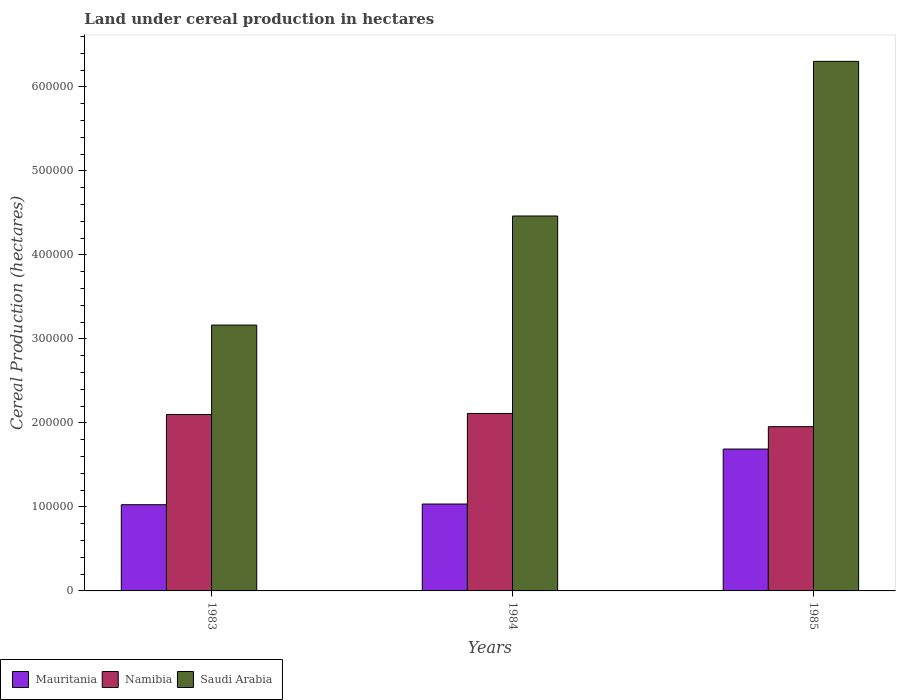How many groups of bars are there?
Provide a succinct answer. 3. Are the number of bars on each tick of the X-axis equal?
Your answer should be compact. Yes. How many bars are there on the 3rd tick from the left?
Offer a terse response. 3. What is the label of the 3rd group of bars from the left?
Your response must be concise. 1985. What is the land under cereal production in Mauritania in 1985?
Keep it short and to the point. 1.69e+05. Across all years, what is the maximum land under cereal production in Saudi Arabia?
Provide a short and direct response. 6.30e+05. Across all years, what is the minimum land under cereal production in Namibia?
Offer a very short reply. 1.96e+05. What is the total land under cereal production in Mauritania in the graph?
Give a very brief answer. 3.75e+05. What is the difference between the land under cereal production in Saudi Arabia in 1983 and that in 1984?
Your answer should be compact. -1.30e+05. What is the difference between the land under cereal production in Mauritania in 1983 and the land under cereal production in Namibia in 1985?
Your answer should be very brief. -9.29e+04. What is the average land under cereal production in Namibia per year?
Give a very brief answer. 2.06e+05. In the year 1985, what is the difference between the land under cereal production in Saudi Arabia and land under cereal production in Namibia?
Give a very brief answer. 4.35e+05. What is the ratio of the land under cereal production in Mauritania in 1984 to that in 1985?
Your answer should be very brief. 0.61. What is the difference between the highest and the second highest land under cereal production in Saudi Arabia?
Provide a succinct answer. 1.84e+05. What is the difference between the highest and the lowest land under cereal production in Mauritania?
Your response must be concise. 6.62e+04. What does the 3rd bar from the left in 1983 represents?
Provide a short and direct response. Saudi Arabia. What does the 1st bar from the right in 1984 represents?
Keep it short and to the point. Saudi Arabia. Are the values on the major ticks of Y-axis written in scientific E-notation?
Ensure brevity in your answer.  No. Does the graph contain any zero values?
Offer a very short reply. No. How many legend labels are there?
Offer a very short reply. 3. How are the legend labels stacked?
Make the answer very short. Horizontal. What is the title of the graph?
Provide a short and direct response. Land under cereal production in hectares. What is the label or title of the X-axis?
Give a very brief answer. Years. What is the label or title of the Y-axis?
Give a very brief answer. Cereal Production (hectares). What is the Cereal Production (hectares) of Mauritania in 1983?
Give a very brief answer. 1.03e+05. What is the Cereal Production (hectares) in Namibia in 1983?
Your answer should be very brief. 2.10e+05. What is the Cereal Production (hectares) in Saudi Arabia in 1983?
Your answer should be compact. 3.16e+05. What is the Cereal Production (hectares) in Mauritania in 1984?
Provide a short and direct response. 1.03e+05. What is the Cereal Production (hectares) in Namibia in 1984?
Ensure brevity in your answer.  2.11e+05. What is the Cereal Production (hectares) in Saudi Arabia in 1984?
Give a very brief answer. 4.46e+05. What is the Cereal Production (hectares) of Mauritania in 1985?
Provide a succinct answer. 1.69e+05. What is the Cereal Production (hectares) of Namibia in 1985?
Make the answer very short. 1.96e+05. What is the Cereal Production (hectares) in Saudi Arabia in 1985?
Offer a very short reply. 6.30e+05. Across all years, what is the maximum Cereal Production (hectares) of Mauritania?
Keep it short and to the point. 1.69e+05. Across all years, what is the maximum Cereal Production (hectares) in Namibia?
Offer a very short reply. 2.11e+05. Across all years, what is the maximum Cereal Production (hectares) in Saudi Arabia?
Give a very brief answer. 6.30e+05. Across all years, what is the minimum Cereal Production (hectares) of Mauritania?
Provide a short and direct response. 1.03e+05. Across all years, what is the minimum Cereal Production (hectares) in Namibia?
Provide a short and direct response. 1.96e+05. Across all years, what is the minimum Cereal Production (hectares) in Saudi Arabia?
Keep it short and to the point. 3.16e+05. What is the total Cereal Production (hectares) in Mauritania in the graph?
Your response must be concise. 3.75e+05. What is the total Cereal Production (hectares) in Namibia in the graph?
Your answer should be compact. 6.17e+05. What is the total Cereal Production (hectares) of Saudi Arabia in the graph?
Keep it short and to the point. 1.39e+06. What is the difference between the Cereal Production (hectares) of Mauritania in 1983 and that in 1984?
Ensure brevity in your answer.  -803. What is the difference between the Cereal Production (hectares) in Namibia in 1983 and that in 1984?
Give a very brief answer. -1200. What is the difference between the Cereal Production (hectares) in Saudi Arabia in 1983 and that in 1984?
Provide a succinct answer. -1.30e+05. What is the difference between the Cereal Production (hectares) of Mauritania in 1983 and that in 1985?
Your answer should be very brief. -6.62e+04. What is the difference between the Cereal Production (hectares) in Namibia in 1983 and that in 1985?
Keep it short and to the point. 1.45e+04. What is the difference between the Cereal Production (hectares) of Saudi Arabia in 1983 and that in 1985?
Provide a short and direct response. -3.14e+05. What is the difference between the Cereal Production (hectares) in Mauritania in 1984 and that in 1985?
Your response must be concise. -6.54e+04. What is the difference between the Cereal Production (hectares) of Namibia in 1984 and that in 1985?
Offer a terse response. 1.57e+04. What is the difference between the Cereal Production (hectares) in Saudi Arabia in 1984 and that in 1985?
Your answer should be compact. -1.84e+05. What is the difference between the Cereal Production (hectares) of Mauritania in 1983 and the Cereal Production (hectares) of Namibia in 1984?
Ensure brevity in your answer.  -1.09e+05. What is the difference between the Cereal Production (hectares) in Mauritania in 1983 and the Cereal Production (hectares) in Saudi Arabia in 1984?
Offer a very short reply. -3.44e+05. What is the difference between the Cereal Production (hectares) of Namibia in 1983 and the Cereal Production (hectares) of Saudi Arabia in 1984?
Your answer should be compact. -2.36e+05. What is the difference between the Cereal Production (hectares) of Mauritania in 1983 and the Cereal Production (hectares) of Namibia in 1985?
Your response must be concise. -9.29e+04. What is the difference between the Cereal Production (hectares) in Mauritania in 1983 and the Cereal Production (hectares) in Saudi Arabia in 1985?
Your answer should be compact. -5.28e+05. What is the difference between the Cereal Production (hectares) of Namibia in 1983 and the Cereal Production (hectares) of Saudi Arabia in 1985?
Offer a very short reply. -4.20e+05. What is the difference between the Cereal Production (hectares) in Mauritania in 1984 and the Cereal Production (hectares) in Namibia in 1985?
Give a very brief answer. -9.21e+04. What is the difference between the Cereal Production (hectares) in Mauritania in 1984 and the Cereal Production (hectares) in Saudi Arabia in 1985?
Keep it short and to the point. -5.27e+05. What is the difference between the Cereal Production (hectares) of Namibia in 1984 and the Cereal Production (hectares) of Saudi Arabia in 1985?
Provide a short and direct response. -4.19e+05. What is the average Cereal Production (hectares) in Mauritania per year?
Offer a terse response. 1.25e+05. What is the average Cereal Production (hectares) of Namibia per year?
Make the answer very short. 2.06e+05. What is the average Cereal Production (hectares) of Saudi Arabia per year?
Ensure brevity in your answer.  4.64e+05. In the year 1983, what is the difference between the Cereal Production (hectares) in Mauritania and Cereal Production (hectares) in Namibia?
Keep it short and to the point. -1.07e+05. In the year 1983, what is the difference between the Cereal Production (hectares) in Mauritania and Cereal Production (hectares) in Saudi Arabia?
Provide a short and direct response. -2.14e+05. In the year 1983, what is the difference between the Cereal Production (hectares) in Namibia and Cereal Production (hectares) in Saudi Arabia?
Offer a terse response. -1.06e+05. In the year 1984, what is the difference between the Cereal Production (hectares) of Mauritania and Cereal Production (hectares) of Namibia?
Give a very brief answer. -1.08e+05. In the year 1984, what is the difference between the Cereal Production (hectares) in Mauritania and Cereal Production (hectares) in Saudi Arabia?
Make the answer very short. -3.43e+05. In the year 1984, what is the difference between the Cereal Production (hectares) in Namibia and Cereal Production (hectares) in Saudi Arabia?
Keep it short and to the point. -2.35e+05. In the year 1985, what is the difference between the Cereal Production (hectares) in Mauritania and Cereal Production (hectares) in Namibia?
Your answer should be compact. -2.66e+04. In the year 1985, what is the difference between the Cereal Production (hectares) in Mauritania and Cereal Production (hectares) in Saudi Arabia?
Provide a succinct answer. -4.61e+05. In the year 1985, what is the difference between the Cereal Production (hectares) of Namibia and Cereal Production (hectares) of Saudi Arabia?
Your answer should be compact. -4.35e+05. What is the ratio of the Cereal Production (hectares) in Saudi Arabia in 1983 to that in 1984?
Offer a very short reply. 0.71. What is the ratio of the Cereal Production (hectares) of Mauritania in 1983 to that in 1985?
Offer a terse response. 0.61. What is the ratio of the Cereal Production (hectares) in Namibia in 1983 to that in 1985?
Offer a very short reply. 1.07. What is the ratio of the Cereal Production (hectares) of Saudi Arabia in 1983 to that in 1985?
Offer a very short reply. 0.5. What is the ratio of the Cereal Production (hectares) of Mauritania in 1984 to that in 1985?
Your answer should be very brief. 0.61. What is the ratio of the Cereal Production (hectares) in Namibia in 1984 to that in 1985?
Provide a succinct answer. 1.08. What is the ratio of the Cereal Production (hectares) in Saudi Arabia in 1984 to that in 1985?
Ensure brevity in your answer.  0.71. What is the difference between the highest and the second highest Cereal Production (hectares) of Mauritania?
Offer a terse response. 6.54e+04. What is the difference between the highest and the second highest Cereal Production (hectares) of Namibia?
Provide a succinct answer. 1200. What is the difference between the highest and the second highest Cereal Production (hectares) of Saudi Arabia?
Offer a very short reply. 1.84e+05. What is the difference between the highest and the lowest Cereal Production (hectares) of Mauritania?
Keep it short and to the point. 6.62e+04. What is the difference between the highest and the lowest Cereal Production (hectares) in Namibia?
Keep it short and to the point. 1.57e+04. What is the difference between the highest and the lowest Cereal Production (hectares) in Saudi Arabia?
Your response must be concise. 3.14e+05. 